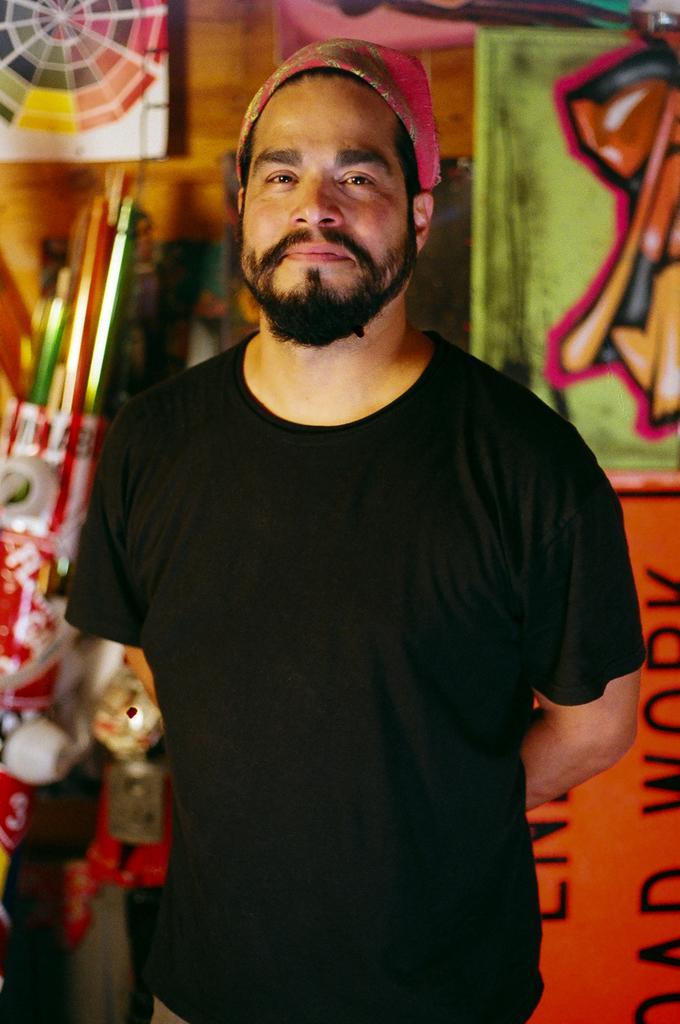Describe this image in one or two sentences. In this image we can see a person wearing black t shirt and a cap is standing. In the background we can see a dartboard and group of poles. 